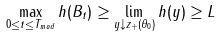<formula> <loc_0><loc_0><loc_500><loc_500>\max _ { 0 \leq t \leq T _ { m o d } } h ( B _ { t } ) \geq \lim _ { y \downarrow z _ { + } ( \theta _ { 0 } ) } h ( y ) \geq L</formula> 